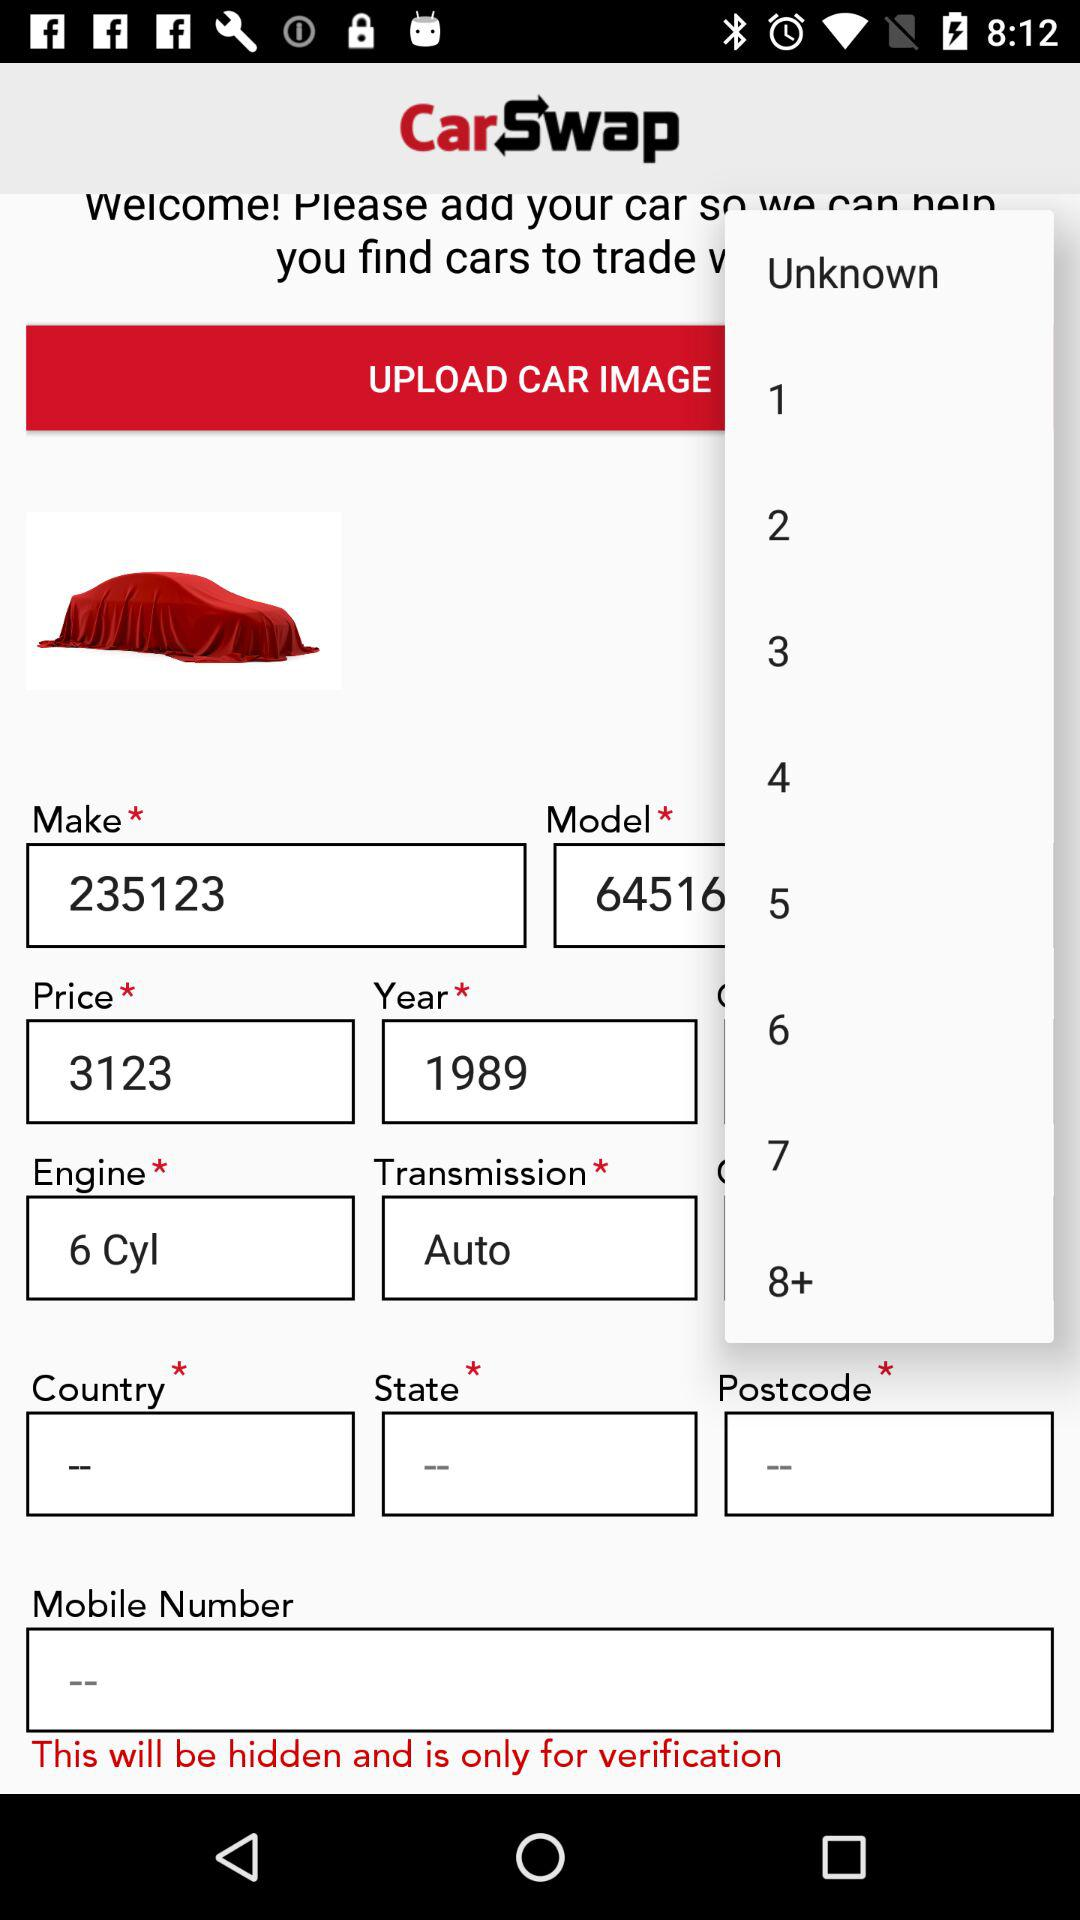What is the type of transmission system? The type of transmission system is automatic. 